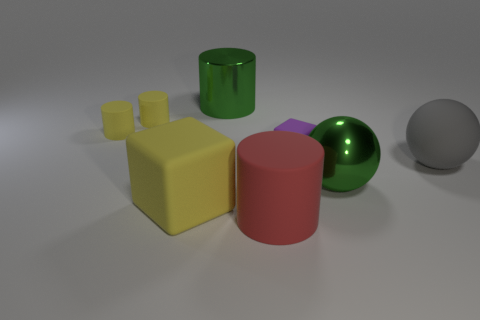Subtract all big matte cylinders. How many cylinders are left? 3 Subtract all green balls. How many balls are left? 1 Subtract all balls. How many objects are left? 6 Subtract 1 cubes. How many cubes are left? 1 Subtract all brown spheres. How many yellow cylinders are left? 2 Add 2 big brown rubber blocks. How many objects exist? 10 Subtract 0 brown balls. How many objects are left? 8 Subtract all brown spheres. Subtract all cyan cubes. How many spheres are left? 2 Subtract all cyan things. Subtract all small yellow cylinders. How many objects are left? 6 Add 8 purple blocks. How many purple blocks are left? 9 